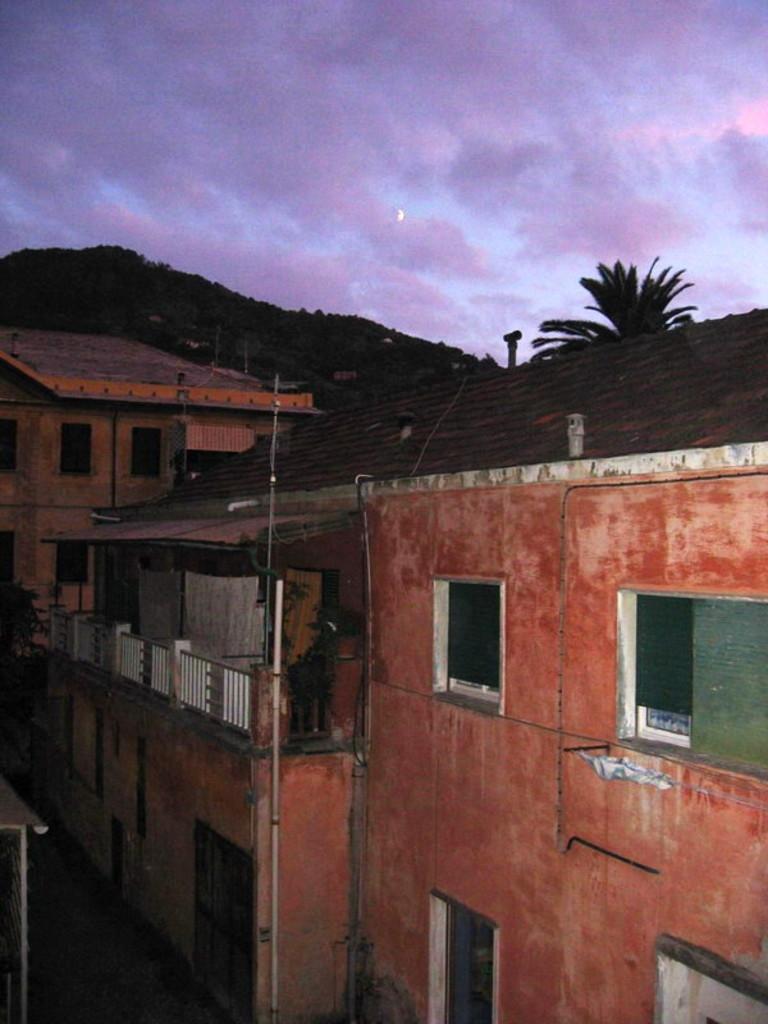Can you describe this image briefly? In this image there are buildings and also trees and a mountain with full of trees is present. At the top there is sky with clouds. 